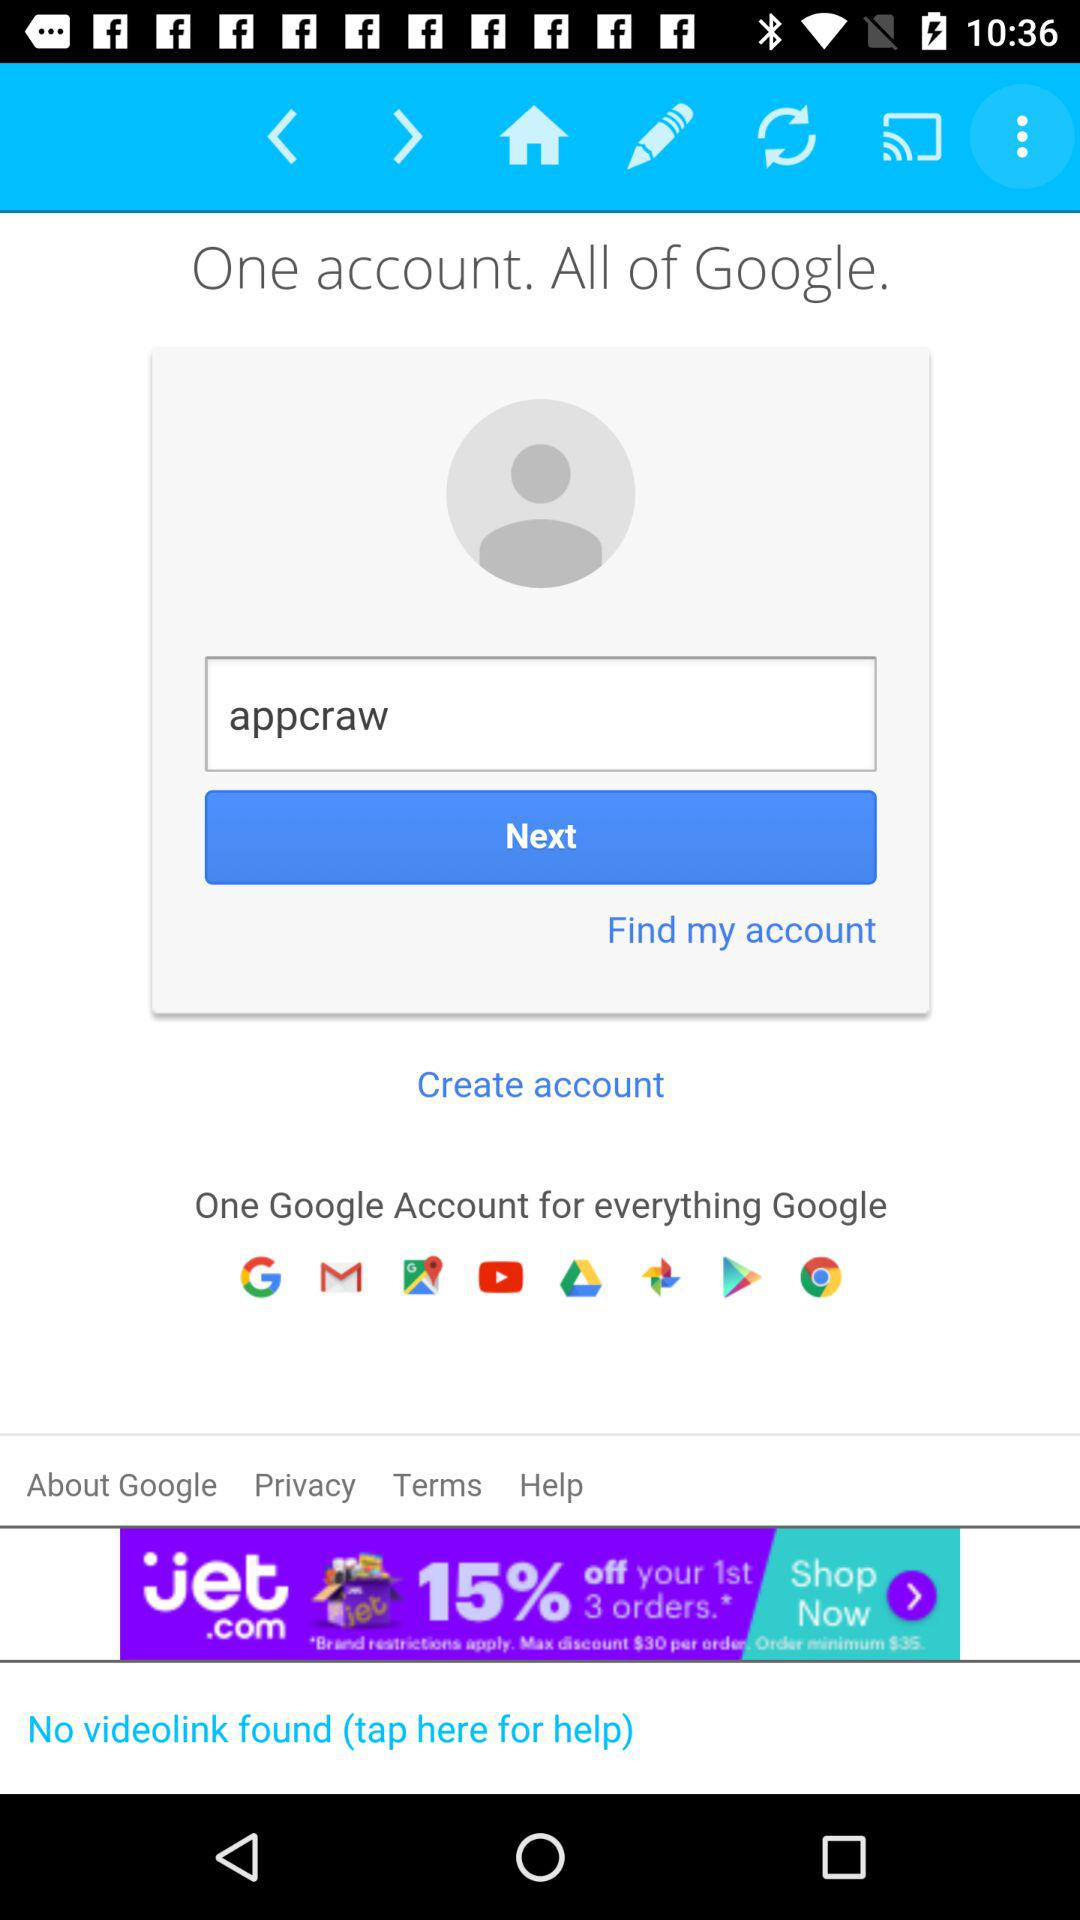For which other applications will one Google account be used? The applications that will be used for one Google account are "Google", "Gmail", "Google Maps", "YouTube", "Google Drive", "Google Photos", "Play Store" and "Chrome". 